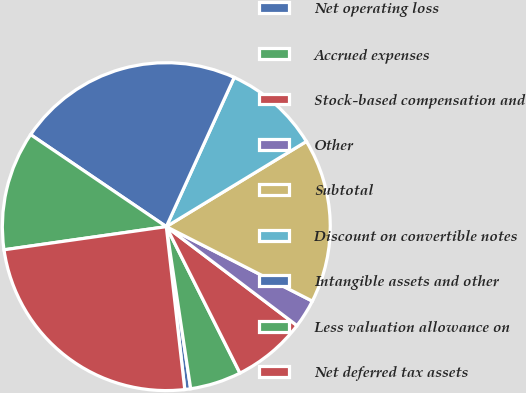<chart> <loc_0><loc_0><loc_500><loc_500><pie_chart><fcel>Net operating loss<fcel>Accrued expenses<fcel>Stock-based compensation and<fcel>Other<fcel>Subtotal<fcel>Discount on convertible notes<fcel>Intangible assets and other<fcel>Less valuation allowance on<fcel>Net deferred tax assets<nl><fcel>0.58%<fcel>5.04%<fcel>7.27%<fcel>2.81%<fcel>16.2%<fcel>9.51%<fcel>22.31%<fcel>11.74%<fcel>24.54%<nl></chart> 